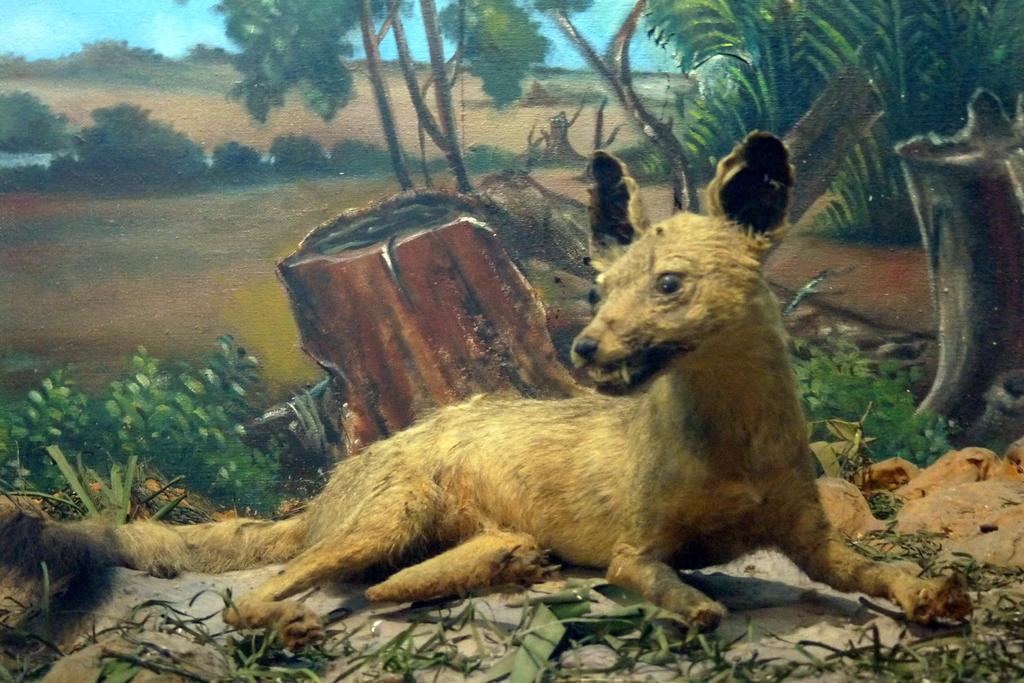Describe this image in one or two sentences. In this image we can see a painting. In the painting there are dog lying on the ground, trees, bushes, shrubs, grass and sky with clouds. 